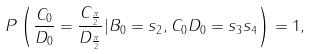<formula> <loc_0><loc_0><loc_500><loc_500>P \left ( \frac { { C } _ { 0 } } { { D } _ { 0 } } = \frac { { C } _ { \frac { \pi } { 2 } } } { { D } _ { \frac { \pi } { 2 } } } | { B } _ { 0 } = s _ { 2 } , { C } _ { 0 } { D } _ { 0 } = s _ { 3 } s _ { 4 } \right ) = 1 ,</formula> 